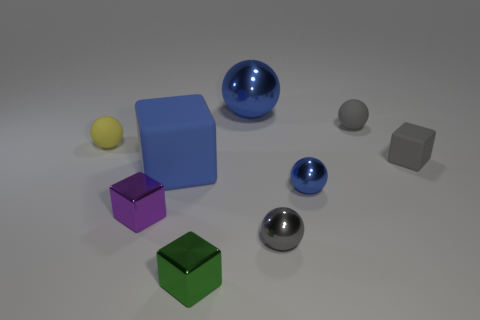There is a block that is the same color as the big shiny object; what is its size?
Give a very brief answer. Large. Are there more green metal things than large blue cylinders?
Offer a terse response. Yes. How many small green things have the same material as the yellow ball?
Your answer should be very brief. 0. Does the gray metallic object have the same shape as the tiny yellow matte thing?
Keep it short and to the point. Yes. What size is the blue metal sphere on the left side of the blue ball that is right of the big object on the right side of the green thing?
Provide a succinct answer. Large. There is a blue thing behind the big blue rubber object; is there a tiny purple block that is in front of it?
Your answer should be compact. Yes. What number of tiny purple things are behind the shiny object in front of the tiny gray ball that is in front of the blue matte object?
Give a very brief answer. 1. What is the color of the tiny block that is both right of the blue rubber block and in front of the big blue matte object?
Make the answer very short. Green. How many metallic things have the same color as the tiny matte cube?
Provide a short and direct response. 1. How many blocks are purple metal things or big blue matte objects?
Your answer should be compact. 2. 